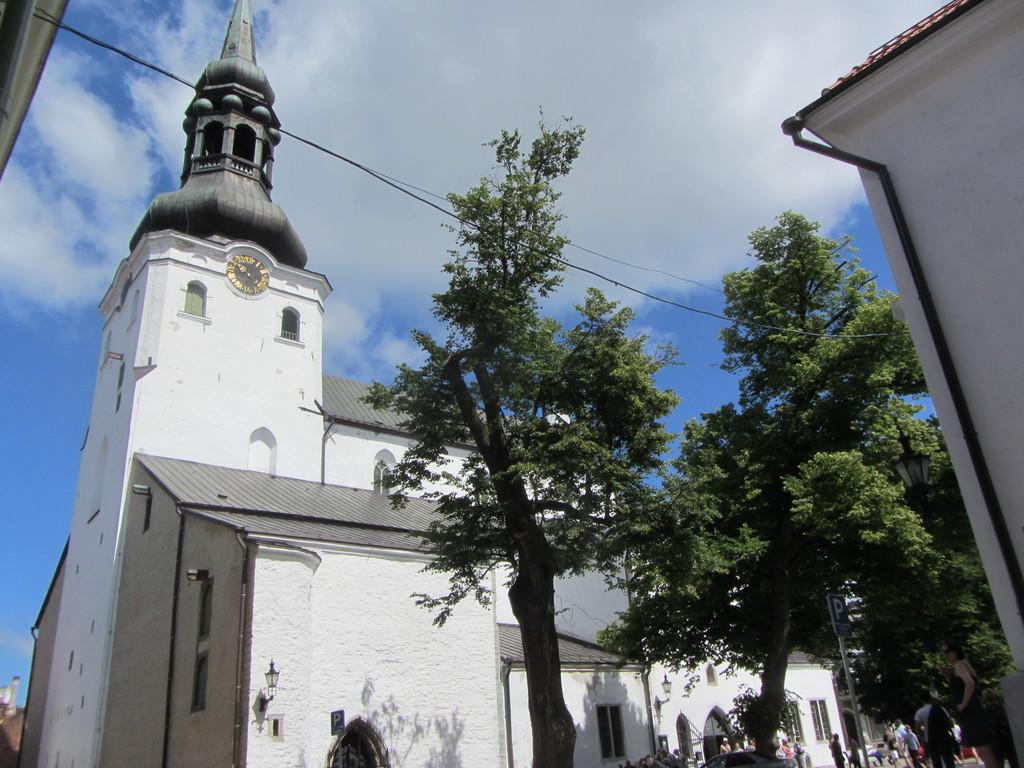What type of vegetation is on the right side of the image? There are trees on the right side of the image. What structure is located on the left side of the image? There is a building on the left side of the image. What feature can be seen on the building? The building has a clock in the middle. What is visible in the image besides the trees and building? The sky is visible in the image. What can be observed in the sky? Clouds are present in the sky. What thought is the fireman having while standing near the building in the image? There is no fireman present in the image, so it is not possible to determine any thoughts they might be having. What type of thread is being used to hold the clouds together in the image? There is no thread present in the image; the clouds are naturally occurring in the sky. 